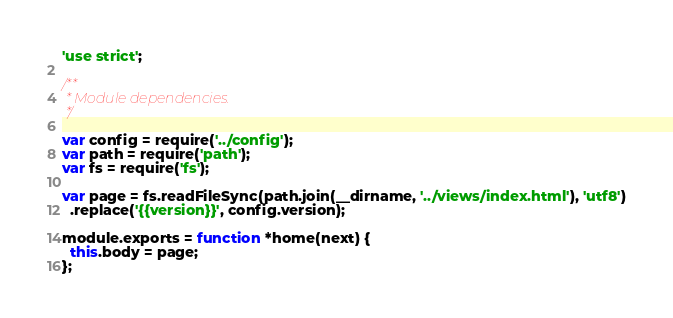Convert code to text. <code><loc_0><loc_0><loc_500><loc_500><_JavaScript_>'use strict';

/**
 * Module dependencies.
 */

var config = require('../config');
var path = require('path');
var fs = require('fs');

var page = fs.readFileSync(path.join(__dirname, '../views/index.html'), 'utf8')
  .replace('{{version}}', config.version);

module.exports = function *home(next) {
  this.body = page;
};
</code> 